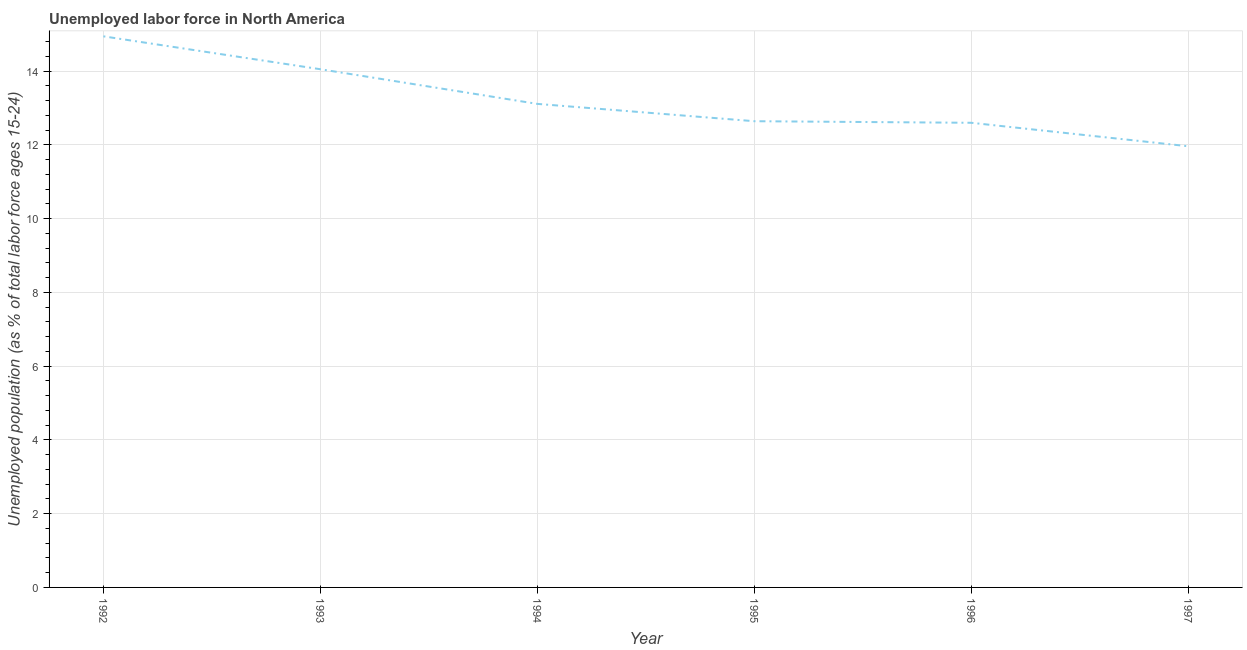What is the total unemployed youth population in 1994?
Keep it short and to the point. 13.11. Across all years, what is the maximum total unemployed youth population?
Provide a succinct answer. 14.95. Across all years, what is the minimum total unemployed youth population?
Offer a terse response. 11.96. In which year was the total unemployed youth population maximum?
Keep it short and to the point. 1992. What is the sum of the total unemployed youth population?
Your answer should be compact. 79.32. What is the difference between the total unemployed youth population in 1992 and 1997?
Keep it short and to the point. 2.98. What is the average total unemployed youth population per year?
Provide a short and direct response. 13.22. What is the median total unemployed youth population?
Give a very brief answer. 12.88. Do a majority of the years between 1995 and 1994 (inclusive) have total unemployed youth population greater than 13.6 %?
Ensure brevity in your answer.  No. What is the ratio of the total unemployed youth population in 1994 to that in 1995?
Give a very brief answer. 1.04. What is the difference between the highest and the second highest total unemployed youth population?
Offer a very short reply. 0.89. What is the difference between the highest and the lowest total unemployed youth population?
Provide a short and direct response. 2.98. In how many years, is the total unemployed youth population greater than the average total unemployed youth population taken over all years?
Make the answer very short. 2. Does the total unemployed youth population monotonically increase over the years?
Make the answer very short. No. How many lines are there?
Your response must be concise. 1. How many years are there in the graph?
Offer a very short reply. 6. What is the difference between two consecutive major ticks on the Y-axis?
Your answer should be very brief. 2. Does the graph contain any zero values?
Provide a short and direct response. No. What is the title of the graph?
Ensure brevity in your answer.  Unemployed labor force in North America. What is the label or title of the Y-axis?
Your response must be concise. Unemployed population (as % of total labor force ages 15-24). What is the Unemployed population (as % of total labor force ages 15-24) of 1992?
Your answer should be very brief. 14.95. What is the Unemployed population (as % of total labor force ages 15-24) of 1993?
Provide a succinct answer. 14.05. What is the Unemployed population (as % of total labor force ages 15-24) of 1994?
Your answer should be compact. 13.11. What is the Unemployed population (as % of total labor force ages 15-24) of 1995?
Ensure brevity in your answer.  12.64. What is the Unemployed population (as % of total labor force ages 15-24) in 1996?
Provide a succinct answer. 12.6. What is the Unemployed population (as % of total labor force ages 15-24) in 1997?
Ensure brevity in your answer.  11.96. What is the difference between the Unemployed population (as % of total labor force ages 15-24) in 1992 and 1993?
Offer a terse response. 0.89. What is the difference between the Unemployed population (as % of total labor force ages 15-24) in 1992 and 1994?
Provide a succinct answer. 1.83. What is the difference between the Unemployed population (as % of total labor force ages 15-24) in 1992 and 1995?
Provide a succinct answer. 2.3. What is the difference between the Unemployed population (as % of total labor force ages 15-24) in 1992 and 1996?
Offer a terse response. 2.34. What is the difference between the Unemployed population (as % of total labor force ages 15-24) in 1992 and 1997?
Offer a terse response. 2.98. What is the difference between the Unemployed population (as % of total labor force ages 15-24) in 1993 and 1994?
Offer a terse response. 0.94. What is the difference between the Unemployed population (as % of total labor force ages 15-24) in 1993 and 1995?
Offer a terse response. 1.41. What is the difference between the Unemployed population (as % of total labor force ages 15-24) in 1993 and 1996?
Ensure brevity in your answer.  1.45. What is the difference between the Unemployed population (as % of total labor force ages 15-24) in 1993 and 1997?
Offer a terse response. 2.09. What is the difference between the Unemployed population (as % of total labor force ages 15-24) in 1994 and 1995?
Keep it short and to the point. 0.47. What is the difference between the Unemployed population (as % of total labor force ages 15-24) in 1994 and 1996?
Provide a succinct answer. 0.51. What is the difference between the Unemployed population (as % of total labor force ages 15-24) in 1994 and 1997?
Make the answer very short. 1.15. What is the difference between the Unemployed population (as % of total labor force ages 15-24) in 1995 and 1996?
Offer a terse response. 0.04. What is the difference between the Unemployed population (as % of total labor force ages 15-24) in 1995 and 1997?
Offer a very short reply. 0.68. What is the difference between the Unemployed population (as % of total labor force ages 15-24) in 1996 and 1997?
Provide a succinct answer. 0.64. What is the ratio of the Unemployed population (as % of total labor force ages 15-24) in 1992 to that in 1993?
Give a very brief answer. 1.06. What is the ratio of the Unemployed population (as % of total labor force ages 15-24) in 1992 to that in 1994?
Ensure brevity in your answer.  1.14. What is the ratio of the Unemployed population (as % of total labor force ages 15-24) in 1992 to that in 1995?
Keep it short and to the point. 1.18. What is the ratio of the Unemployed population (as % of total labor force ages 15-24) in 1992 to that in 1996?
Your response must be concise. 1.19. What is the ratio of the Unemployed population (as % of total labor force ages 15-24) in 1992 to that in 1997?
Provide a succinct answer. 1.25. What is the ratio of the Unemployed population (as % of total labor force ages 15-24) in 1993 to that in 1994?
Keep it short and to the point. 1.07. What is the ratio of the Unemployed population (as % of total labor force ages 15-24) in 1993 to that in 1995?
Make the answer very short. 1.11. What is the ratio of the Unemployed population (as % of total labor force ages 15-24) in 1993 to that in 1996?
Offer a very short reply. 1.11. What is the ratio of the Unemployed population (as % of total labor force ages 15-24) in 1993 to that in 1997?
Your response must be concise. 1.18. What is the ratio of the Unemployed population (as % of total labor force ages 15-24) in 1994 to that in 1996?
Offer a terse response. 1.04. What is the ratio of the Unemployed population (as % of total labor force ages 15-24) in 1994 to that in 1997?
Your answer should be compact. 1.1. What is the ratio of the Unemployed population (as % of total labor force ages 15-24) in 1995 to that in 1996?
Offer a very short reply. 1. What is the ratio of the Unemployed population (as % of total labor force ages 15-24) in 1995 to that in 1997?
Your answer should be very brief. 1.06. What is the ratio of the Unemployed population (as % of total labor force ages 15-24) in 1996 to that in 1997?
Your response must be concise. 1.05. 